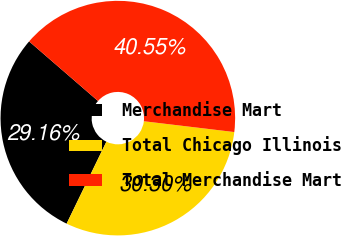<chart> <loc_0><loc_0><loc_500><loc_500><pie_chart><fcel>Merchandise Mart<fcel>Total Chicago Illinois<fcel>Total Merchandise Mart<nl><fcel>29.16%<fcel>30.3%<fcel>40.55%<nl></chart> 